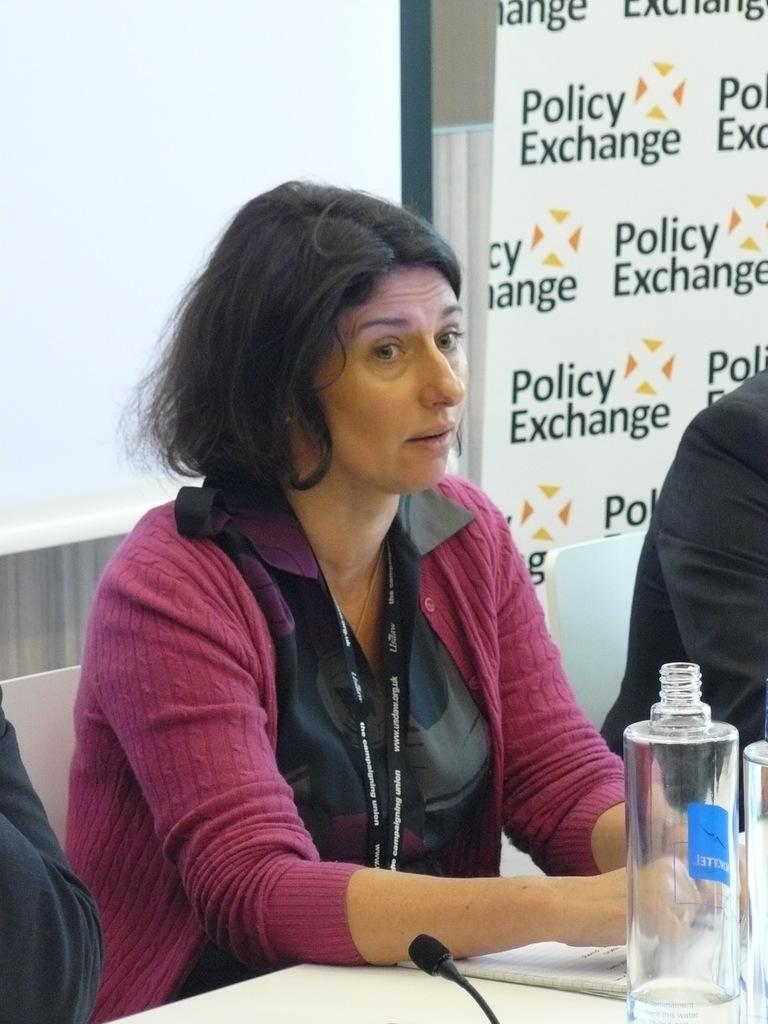<image>
Provide a brief description of the given image. A worried looking woman sits next to a wall with the words policy exchange repeated on it. 